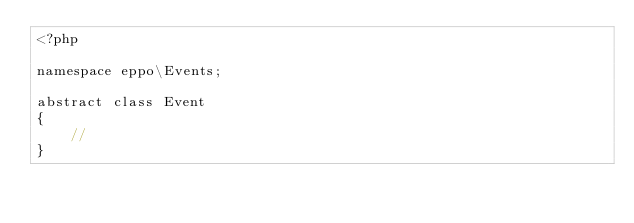<code> <loc_0><loc_0><loc_500><loc_500><_PHP_><?php

namespace eppo\Events;

abstract class Event
{
    //
}
</code> 